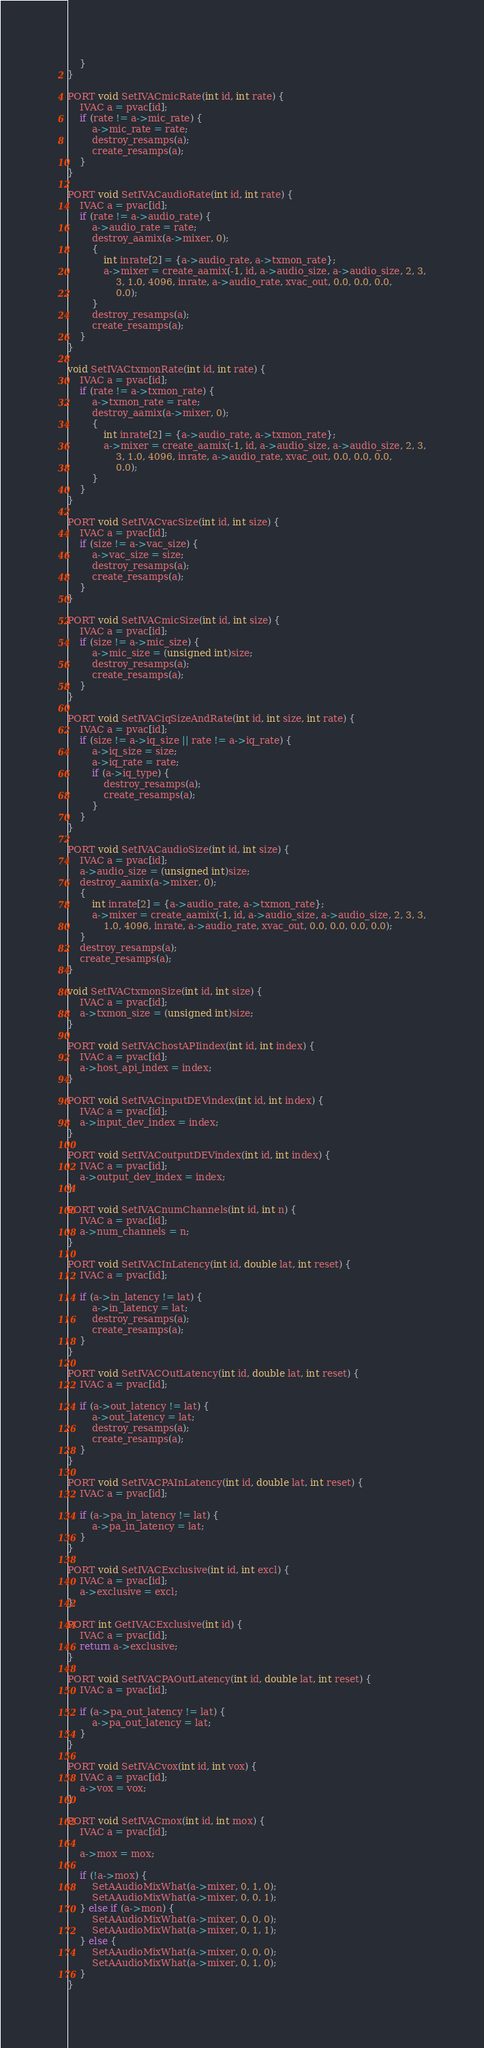<code> <loc_0><loc_0><loc_500><loc_500><_C_>    }
}

PORT void SetIVACmicRate(int id, int rate) {
    IVAC a = pvac[id];
    if (rate != a->mic_rate) {
        a->mic_rate = rate;
        destroy_resamps(a);
        create_resamps(a);
    }
}

PORT void SetIVACaudioRate(int id, int rate) {
    IVAC a = pvac[id];
    if (rate != a->audio_rate) {
        a->audio_rate = rate;
        destroy_aamix(a->mixer, 0);
        {
            int inrate[2] = {a->audio_rate, a->txmon_rate};
            a->mixer = create_aamix(-1, id, a->audio_size, a->audio_size, 2, 3,
                3, 1.0, 4096, inrate, a->audio_rate, xvac_out, 0.0, 0.0, 0.0,
                0.0);
        }
        destroy_resamps(a);
        create_resamps(a);
    }
}

void SetIVACtxmonRate(int id, int rate) {
    IVAC a = pvac[id];
    if (rate != a->txmon_rate) {
        a->txmon_rate = rate;
        destroy_aamix(a->mixer, 0);
        {
            int inrate[2] = {a->audio_rate, a->txmon_rate};
            a->mixer = create_aamix(-1, id, a->audio_size, a->audio_size, 2, 3,
                3, 1.0, 4096, inrate, a->audio_rate, xvac_out, 0.0, 0.0, 0.0,
                0.0);
        }
    }
}

PORT void SetIVACvacSize(int id, int size) {
    IVAC a = pvac[id];
    if (size != a->vac_size) {
        a->vac_size = size;
        destroy_resamps(a);
        create_resamps(a);
    }
}

PORT void SetIVACmicSize(int id, int size) {
    IVAC a = pvac[id];
    if (size != a->mic_size) {
        a->mic_size = (unsigned int)size;
        destroy_resamps(a);
        create_resamps(a);
    }
}

PORT void SetIVACiqSizeAndRate(int id, int size, int rate) {
    IVAC a = pvac[id];
    if (size != a->iq_size || rate != a->iq_rate) {
        a->iq_size = size;
        a->iq_rate = rate;
        if (a->iq_type) {
            destroy_resamps(a);
            create_resamps(a);
        }
    }
}

PORT void SetIVACaudioSize(int id, int size) {
    IVAC a = pvac[id];
    a->audio_size = (unsigned int)size;
    destroy_aamix(a->mixer, 0);
    {
        int inrate[2] = {a->audio_rate, a->txmon_rate};
        a->mixer = create_aamix(-1, id, a->audio_size, a->audio_size, 2, 3, 3,
            1.0, 4096, inrate, a->audio_rate, xvac_out, 0.0, 0.0, 0.0, 0.0);
    }
    destroy_resamps(a);
    create_resamps(a);
}

void SetIVACtxmonSize(int id, int size) {
    IVAC a = pvac[id];
    a->txmon_size = (unsigned int)size;
}

PORT void SetIVAChostAPIindex(int id, int index) {
    IVAC a = pvac[id];
    a->host_api_index = index;
}

PORT void SetIVACinputDEVindex(int id, int index) {
    IVAC a = pvac[id];
    a->input_dev_index = index;
}

PORT void SetIVACoutputDEVindex(int id, int index) {
    IVAC a = pvac[id];
    a->output_dev_index = index;
}

PORT void SetIVACnumChannels(int id, int n) {
    IVAC a = pvac[id];
    a->num_channels = n;
}

PORT void SetIVACInLatency(int id, double lat, int reset) {
    IVAC a = pvac[id];

    if (a->in_latency != lat) {
        a->in_latency = lat;
        destroy_resamps(a);
        create_resamps(a);
    }
}

PORT void SetIVACOutLatency(int id, double lat, int reset) {
    IVAC a = pvac[id];

    if (a->out_latency != lat) {
        a->out_latency = lat;
        destroy_resamps(a);
        create_resamps(a);
    }
}

PORT void SetIVACPAInLatency(int id, double lat, int reset) {
    IVAC a = pvac[id];

    if (a->pa_in_latency != lat) {
        a->pa_in_latency = lat;
    }
}

PORT void SetIVACExclusive(int id, int excl) {
    IVAC a = pvac[id];
    a->exclusive = excl;
}

PORT int GetIVACExclusive(int id) {
    IVAC a = pvac[id];
    return a->exclusive;
}

PORT void SetIVACPAOutLatency(int id, double lat, int reset) {
    IVAC a = pvac[id];

    if (a->pa_out_latency != lat) {
        a->pa_out_latency = lat;
    }
}

PORT void SetIVACvox(int id, int vox) {
    IVAC a = pvac[id];
    a->vox = vox;
}

PORT void SetIVACmox(int id, int mox) {
    IVAC a = pvac[id];

    a->mox = mox;
    
    if (!a->mox) {
        SetAAudioMixWhat(a->mixer, 0, 1, 0);
        SetAAudioMixWhat(a->mixer, 0, 0, 1);
    } else if (a->mon) {
        SetAAudioMixWhat(a->mixer, 0, 0, 0);
        SetAAudioMixWhat(a->mixer, 0, 1, 1);
    } else {
        SetAAudioMixWhat(a->mixer, 0, 0, 0);
        SetAAudioMixWhat(a->mixer, 0, 1, 0);
    }
}
</code> 